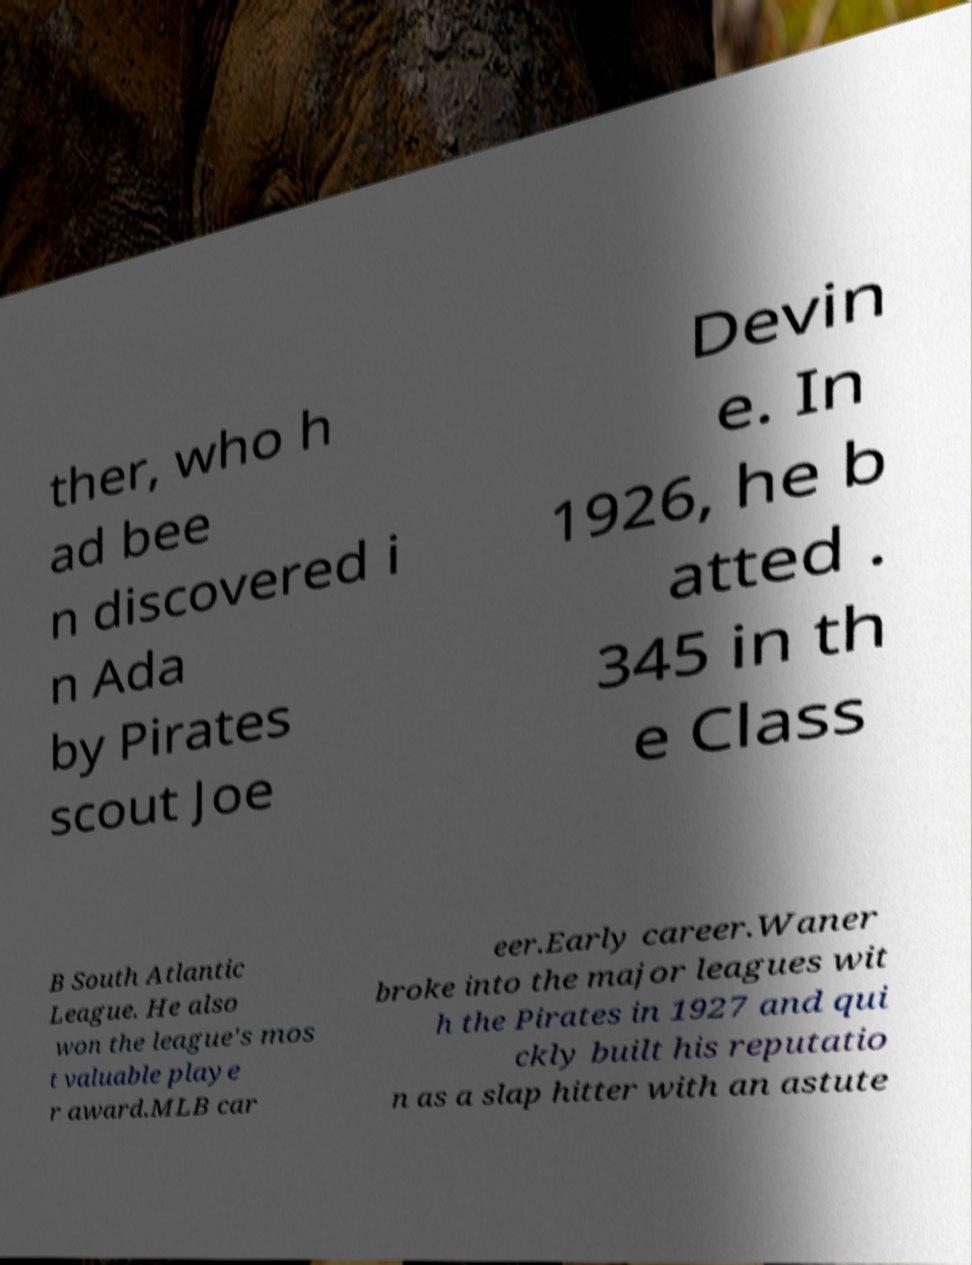Could you extract and type out the text from this image? ther, who h ad bee n discovered i n Ada by Pirates scout Joe Devin e. In 1926, he b atted . 345 in th e Class B South Atlantic League. He also won the league's mos t valuable playe r award.MLB car eer.Early career.Waner broke into the major leagues wit h the Pirates in 1927 and qui ckly built his reputatio n as a slap hitter with an astute 